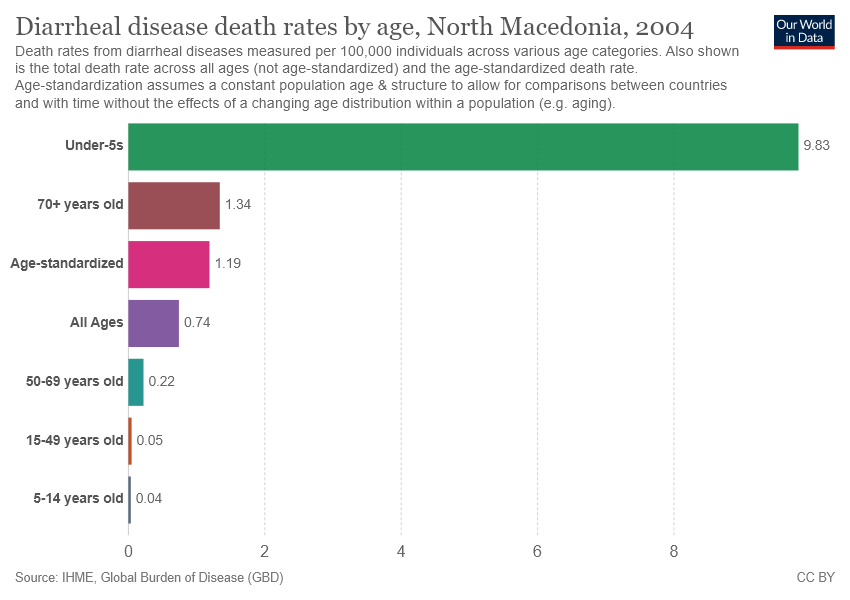Draw attention to some important aspects in this diagram. The group that is in the middle is 'All Ages'. 